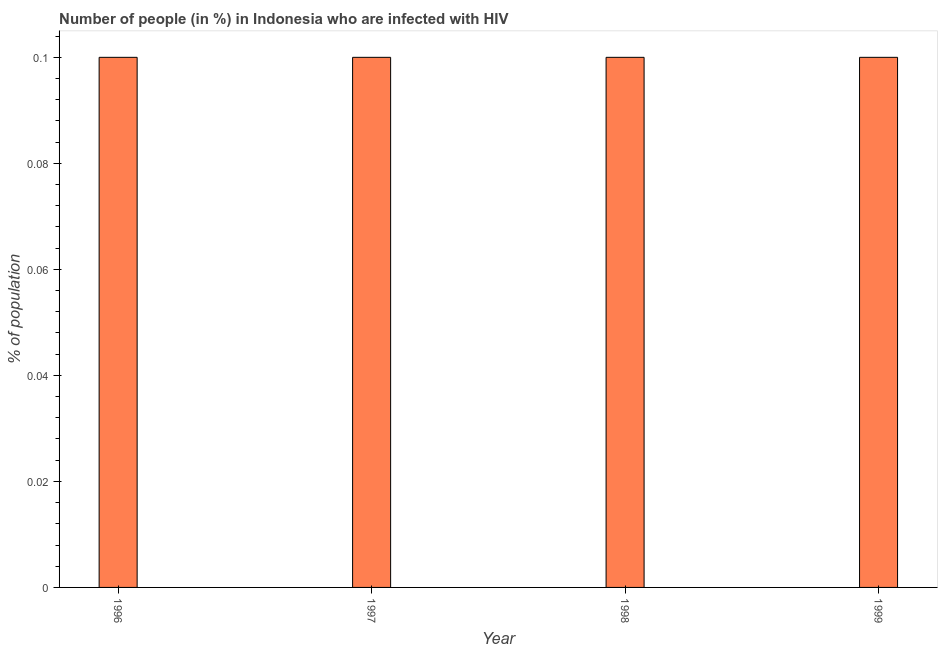Does the graph contain grids?
Make the answer very short. No. What is the title of the graph?
Keep it short and to the point. Number of people (in %) in Indonesia who are infected with HIV. What is the label or title of the X-axis?
Your response must be concise. Year. What is the label or title of the Y-axis?
Provide a succinct answer. % of population. Across all years, what is the minimum number of people infected with hiv?
Keep it short and to the point. 0.1. In which year was the number of people infected with hiv minimum?
Ensure brevity in your answer.  1996. What is the sum of the number of people infected with hiv?
Ensure brevity in your answer.  0.4. In how many years, is the number of people infected with hiv greater than 0.076 %?
Make the answer very short. 4. Do a majority of the years between 1999 and 1997 (inclusive) have number of people infected with hiv greater than 0.072 %?
Provide a succinct answer. Yes. Is the number of people infected with hiv in 1996 less than that in 1999?
Your answer should be very brief. No. Is the difference between the number of people infected with hiv in 1997 and 1998 greater than the difference between any two years?
Give a very brief answer. Yes. What is the difference between the highest and the second highest number of people infected with hiv?
Offer a very short reply. 0. How many bars are there?
Ensure brevity in your answer.  4. What is the difference between two consecutive major ticks on the Y-axis?
Provide a short and direct response. 0.02. Are the values on the major ticks of Y-axis written in scientific E-notation?
Make the answer very short. No. What is the % of population in 1997?
Keep it short and to the point. 0.1. What is the % of population of 1998?
Offer a terse response. 0.1. What is the % of population of 1999?
Make the answer very short. 0.1. What is the difference between the % of population in 1996 and 1997?
Offer a very short reply. 0. What is the difference between the % of population in 1996 and 1998?
Ensure brevity in your answer.  0. What is the difference between the % of population in 1996 and 1999?
Make the answer very short. 0. What is the ratio of the % of population in 1996 to that in 1998?
Give a very brief answer. 1. What is the ratio of the % of population in 1997 to that in 1998?
Offer a very short reply. 1. What is the ratio of the % of population in 1998 to that in 1999?
Provide a succinct answer. 1. 